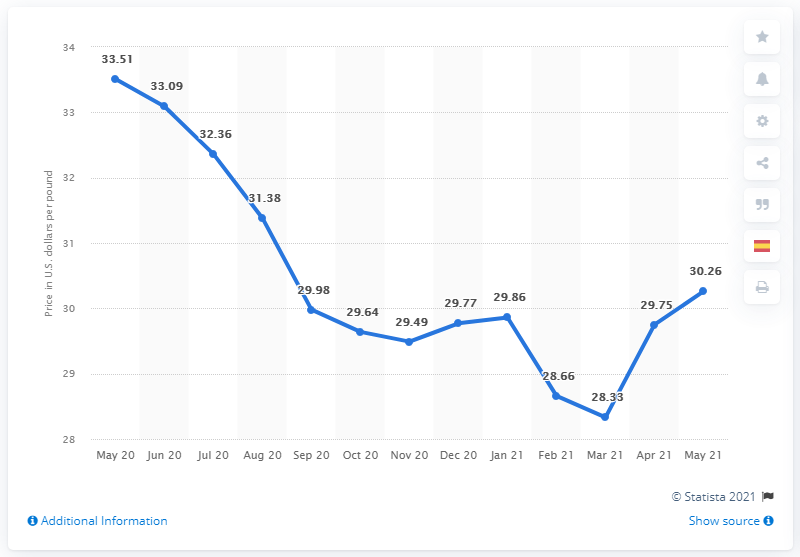Give some essential details in this illustration. The value of the data point changed by 1.93 points between March 21 and May 21. As of March 21, the displayed price was 28.33. 